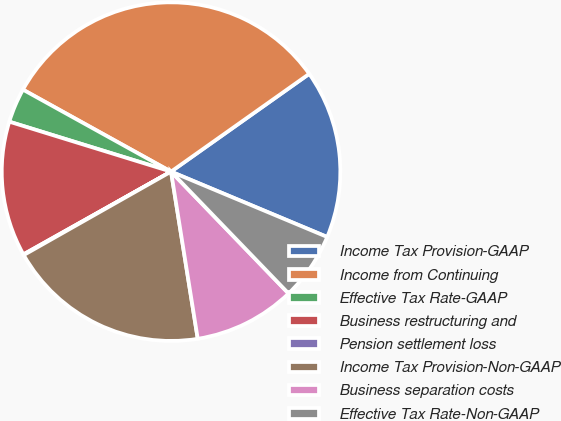<chart> <loc_0><loc_0><loc_500><loc_500><pie_chart><fcel>Income Tax Provision-GAAP<fcel>Income from Continuing<fcel>Effective Tax Rate-GAAP<fcel>Business restructuring and<fcel>Pension settlement loss<fcel>Income Tax Provision-Non-GAAP<fcel>Business separation costs<fcel>Effective Tax Rate-Non-GAAP<nl><fcel>16.11%<fcel>32.15%<fcel>3.28%<fcel>12.9%<fcel>0.07%<fcel>19.32%<fcel>9.69%<fcel>6.48%<nl></chart> 